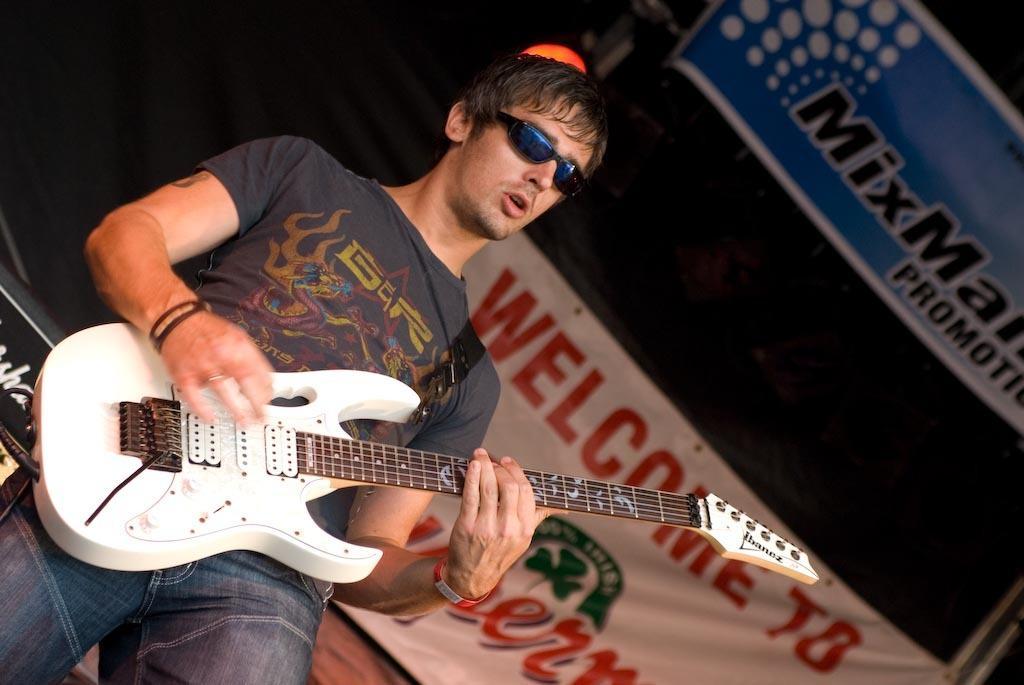Could you give a brief overview of what you see in this image? There is a man who is playing guitar. He has goggles. On the background there is a banner. 